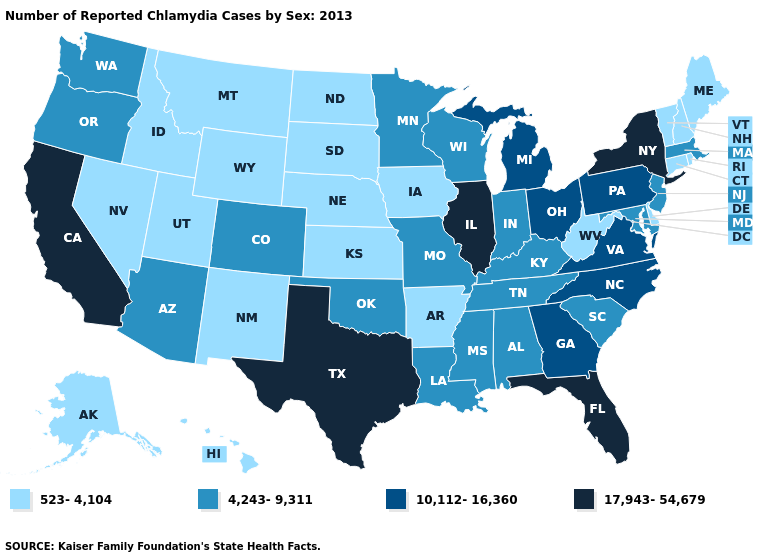What is the value of Massachusetts?
Keep it brief. 4,243-9,311. What is the lowest value in the West?
Answer briefly. 523-4,104. How many symbols are there in the legend?
Write a very short answer. 4. Name the states that have a value in the range 523-4,104?
Be succinct. Alaska, Arkansas, Connecticut, Delaware, Hawaii, Idaho, Iowa, Kansas, Maine, Montana, Nebraska, Nevada, New Hampshire, New Mexico, North Dakota, Rhode Island, South Dakota, Utah, Vermont, West Virginia, Wyoming. What is the value of Arizona?
Answer briefly. 4,243-9,311. Does Massachusetts have a higher value than North Dakota?
Answer briefly. Yes. How many symbols are there in the legend?
Quick response, please. 4. Does Tennessee have the lowest value in the USA?
Give a very brief answer. No. What is the highest value in the USA?
Write a very short answer. 17,943-54,679. Does Wyoming have the lowest value in the USA?
Answer briefly. Yes. Among the states that border Colorado , which have the lowest value?
Give a very brief answer. Kansas, Nebraska, New Mexico, Utah, Wyoming. Does Minnesota have the highest value in the MidWest?
Keep it brief. No. What is the lowest value in states that border Washington?
Answer briefly. 523-4,104. What is the highest value in the South ?
Answer briefly. 17,943-54,679. 